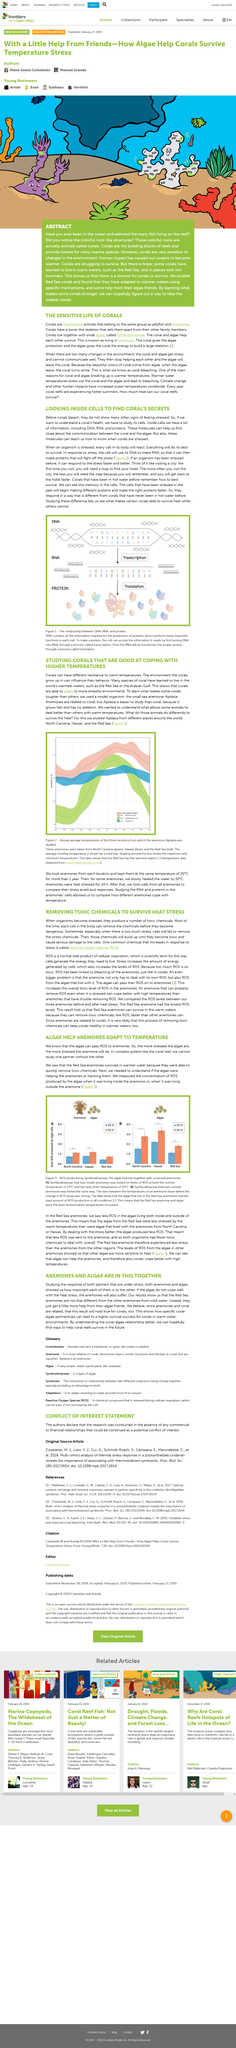Highlight a few significant elements in this photo. When an organism experiences stress, every cell in its body will respond with a reaction. The communication between coral and algae is studied through the use of molecules, which provide clues about their interactions. DNA is a molecule that contains all the necessary information required for the production of proteins, which play essential roles in the function of each cell. The research focused on investigating coral reef regions in North Carolina, Hawaii, and the Red Sea. An investigation into the symbiosis between Anemore and Algae is currently underway. 